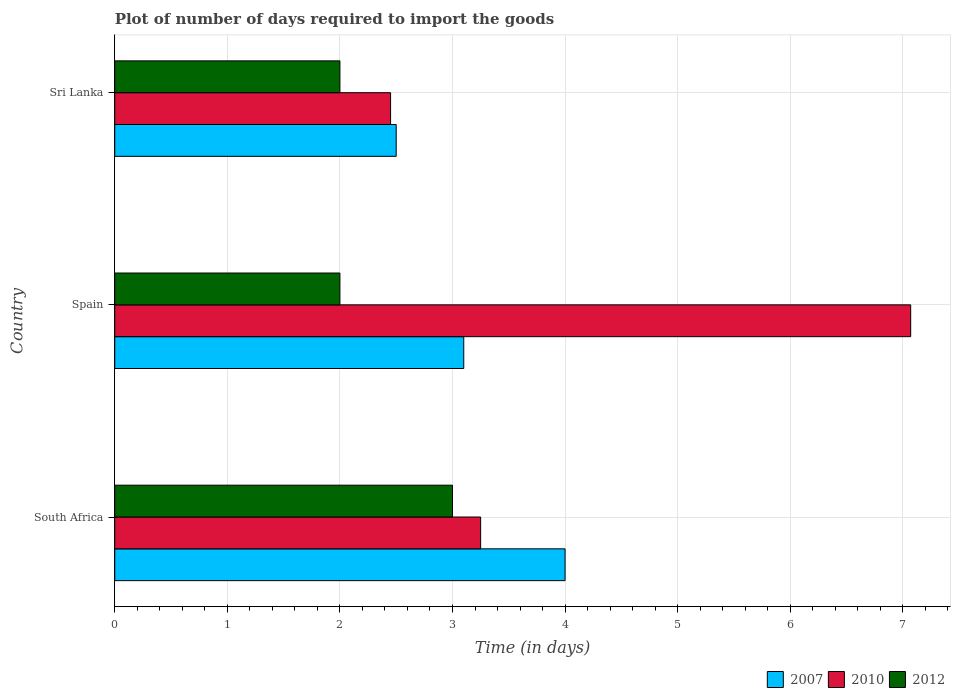Are the number of bars on each tick of the Y-axis equal?
Make the answer very short. Yes. What is the label of the 3rd group of bars from the top?
Provide a short and direct response. South Africa. Across all countries, what is the minimum time required to import goods in 2010?
Offer a very short reply. 2.45. In which country was the time required to import goods in 2012 maximum?
Your response must be concise. South Africa. In which country was the time required to import goods in 2010 minimum?
Provide a succinct answer. Sri Lanka. What is the difference between the time required to import goods in 2010 in South Africa and that in Sri Lanka?
Give a very brief answer. 0.8. What is the difference between the time required to import goods in 2012 in Sri Lanka and the time required to import goods in 2007 in South Africa?
Provide a short and direct response. -2. What is the average time required to import goods in 2007 per country?
Offer a very short reply. 3.2. What is the difference between the time required to import goods in 2007 and time required to import goods in 2010 in South Africa?
Offer a terse response. 0.75. What is the ratio of the time required to import goods in 2012 in South Africa to that in Spain?
Offer a terse response. 1.5. Is the time required to import goods in 2012 in Spain less than that in Sri Lanka?
Make the answer very short. No. Is the difference between the time required to import goods in 2007 in Spain and Sri Lanka greater than the difference between the time required to import goods in 2010 in Spain and Sri Lanka?
Offer a terse response. No. What is the difference between the highest and the second highest time required to import goods in 2010?
Offer a very short reply. 3.82. What is the difference between the highest and the lowest time required to import goods in 2007?
Your answer should be very brief. 1.5. Is the sum of the time required to import goods in 2007 in South Africa and Spain greater than the maximum time required to import goods in 2010 across all countries?
Ensure brevity in your answer.  Yes. Is it the case that in every country, the sum of the time required to import goods in 2012 and time required to import goods in 2010 is greater than the time required to import goods in 2007?
Your response must be concise. Yes. How many bars are there?
Make the answer very short. 9. Are the values on the major ticks of X-axis written in scientific E-notation?
Ensure brevity in your answer.  No. Does the graph contain grids?
Offer a very short reply. Yes. How many legend labels are there?
Your response must be concise. 3. What is the title of the graph?
Make the answer very short. Plot of number of days required to import the goods. Does "2009" appear as one of the legend labels in the graph?
Offer a very short reply. No. What is the label or title of the X-axis?
Make the answer very short. Time (in days). What is the Time (in days) of 2007 in South Africa?
Offer a terse response. 4. What is the Time (in days) of 2012 in South Africa?
Offer a very short reply. 3. What is the Time (in days) of 2010 in Spain?
Ensure brevity in your answer.  7.07. What is the Time (in days) of 2012 in Spain?
Make the answer very short. 2. What is the Time (in days) in 2007 in Sri Lanka?
Make the answer very short. 2.5. What is the Time (in days) in 2010 in Sri Lanka?
Provide a succinct answer. 2.45. What is the Time (in days) in 2012 in Sri Lanka?
Your answer should be very brief. 2. Across all countries, what is the maximum Time (in days) in 2007?
Your response must be concise. 4. Across all countries, what is the maximum Time (in days) in 2010?
Your response must be concise. 7.07. Across all countries, what is the minimum Time (in days) of 2010?
Your answer should be compact. 2.45. What is the total Time (in days) of 2007 in the graph?
Your answer should be compact. 9.6. What is the total Time (in days) of 2010 in the graph?
Offer a terse response. 12.77. What is the difference between the Time (in days) of 2010 in South Africa and that in Spain?
Ensure brevity in your answer.  -3.82. What is the difference between the Time (in days) of 2012 in South Africa and that in Spain?
Your response must be concise. 1. What is the difference between the Time (in days) in 2007 in South Africa and that in Sri Lanka?
Provide a short and direct response. 1.5. What is the difference between the Time (in days) in 2012 in South Africa and that in Sri Lanka?
Offer a terse response. 1. What is the difference between the Time (in days) in 2007 in Spain and that in Sri Lanka?
Keep it short and to the point. 0.6. What is the difference between the Time (in days) in 2010 in Spain and that in Sri Lanka?
Your answer should be compact. 4.62. What is the difference between the Time (in days) in 2007 in South Africa and the Time (in days) in 2010 in Spain?
Give a very brief answer. -3.07. What is the difference between the Time (in days) in 2010 in South Africa and the Time (in days) in 2012 in Spain?
Give a very brief answer. 1.25. What is the difference between the Time (in days) of 2007 in South Africa and the Time (in days) of 2010 in Sri Lanka?
Your answer should be very brief. 1.55. What is the difference between the Time (in days) in 2007 in South Africa and the Time (in days) in 2012 in Sri Lanka?
Your answer should be compact. 2. What is the difference between the Time (in days) in 2007 in Spain and the Time (in days) in 2010 in Sri Lanka?
Provide a succinct answer. 0.65. What is the difference between the Time (in days) in 2010 in Spain and the Time (in days) in 2012 in Sri Lanka?
Your response must be concise. 5.07. What is the average Time (in days) in 2010 per country?
Offer a terse response. 4.26. What is the average Time (in days) of 2012 per country?
Your answer should be compact. 2.33. What is the difference between the Time (in days) of 2007 and Time (in days) of 2010 in Spain?
Offer a very short reply. -3.97. What is the difference between the Time (in days) in 2010 and Time (in days) in 2012 in Spain?
Your answer should be compact. 5.07. What is the difference between the Time (in days) in 2007 and Time (in days) in 2012 in Sri Lanka?
Your response must be concise. 0.5. What is the difference between the Time (in days) of 2010 and Time (in days) of 2012 in Sri Lanka?
Ensure brevity in your answer.  0.45. What is the ratio of the Time (in days) in 2007 in South Africa to that in Spain?
Give a very brief answer. 1.29. What is the ratio of the Time (in days) of 2010 in South Africa to that in Spain?
Keep it short and to the point. 0.46. What is the ratio of the Time (in days) in 2012 in South Africa to that in Spain?
Your answer should be very brief. 1.5. What is the ratio of the Time (in days) in 2010 in South Africa to that in Sri Lanka?
Your answer should be compact. 1.33. What is the ratio of the Time (in days) of 2012 in South Africa to that in Sri Lanka?
Ensure brevity in your answer.  1.5. What is the ratio of the Time (in days) in 2007 in Spain to that in Sri Lanka?
Keep it short and to the point. 1.24. What is the ratio of the Time (in days) of 2010 in Spain to that in Sri Lanka?
Your answer should be very brief. 2.89. What is the ratio of the Time (in days) in 2012 in Spain to that in Sri Lanka?
Offer a very short reply. 1. What is the difference between the highest and the second highest Time (in days) of 2010?
Provide a succinct answer. 3.82. What is the difference between the highest and the lowest Time (in days) in 2010?
Ensure brevity in your answer.  4.62. What is the difference between the highest and the lowest Time (in days) in 2012?
Offer a terse response. 1. 